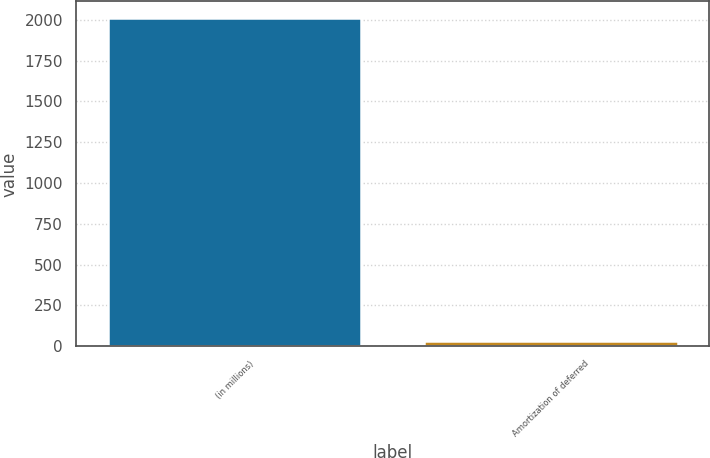Convert chart. <chart><loc_0><loc_0><loc_500><loc_500><bar_chart><fcel>(in millions)<fcel>Amortization of deferred<nl><fcel>2012<fcel>29<nl></chart> 